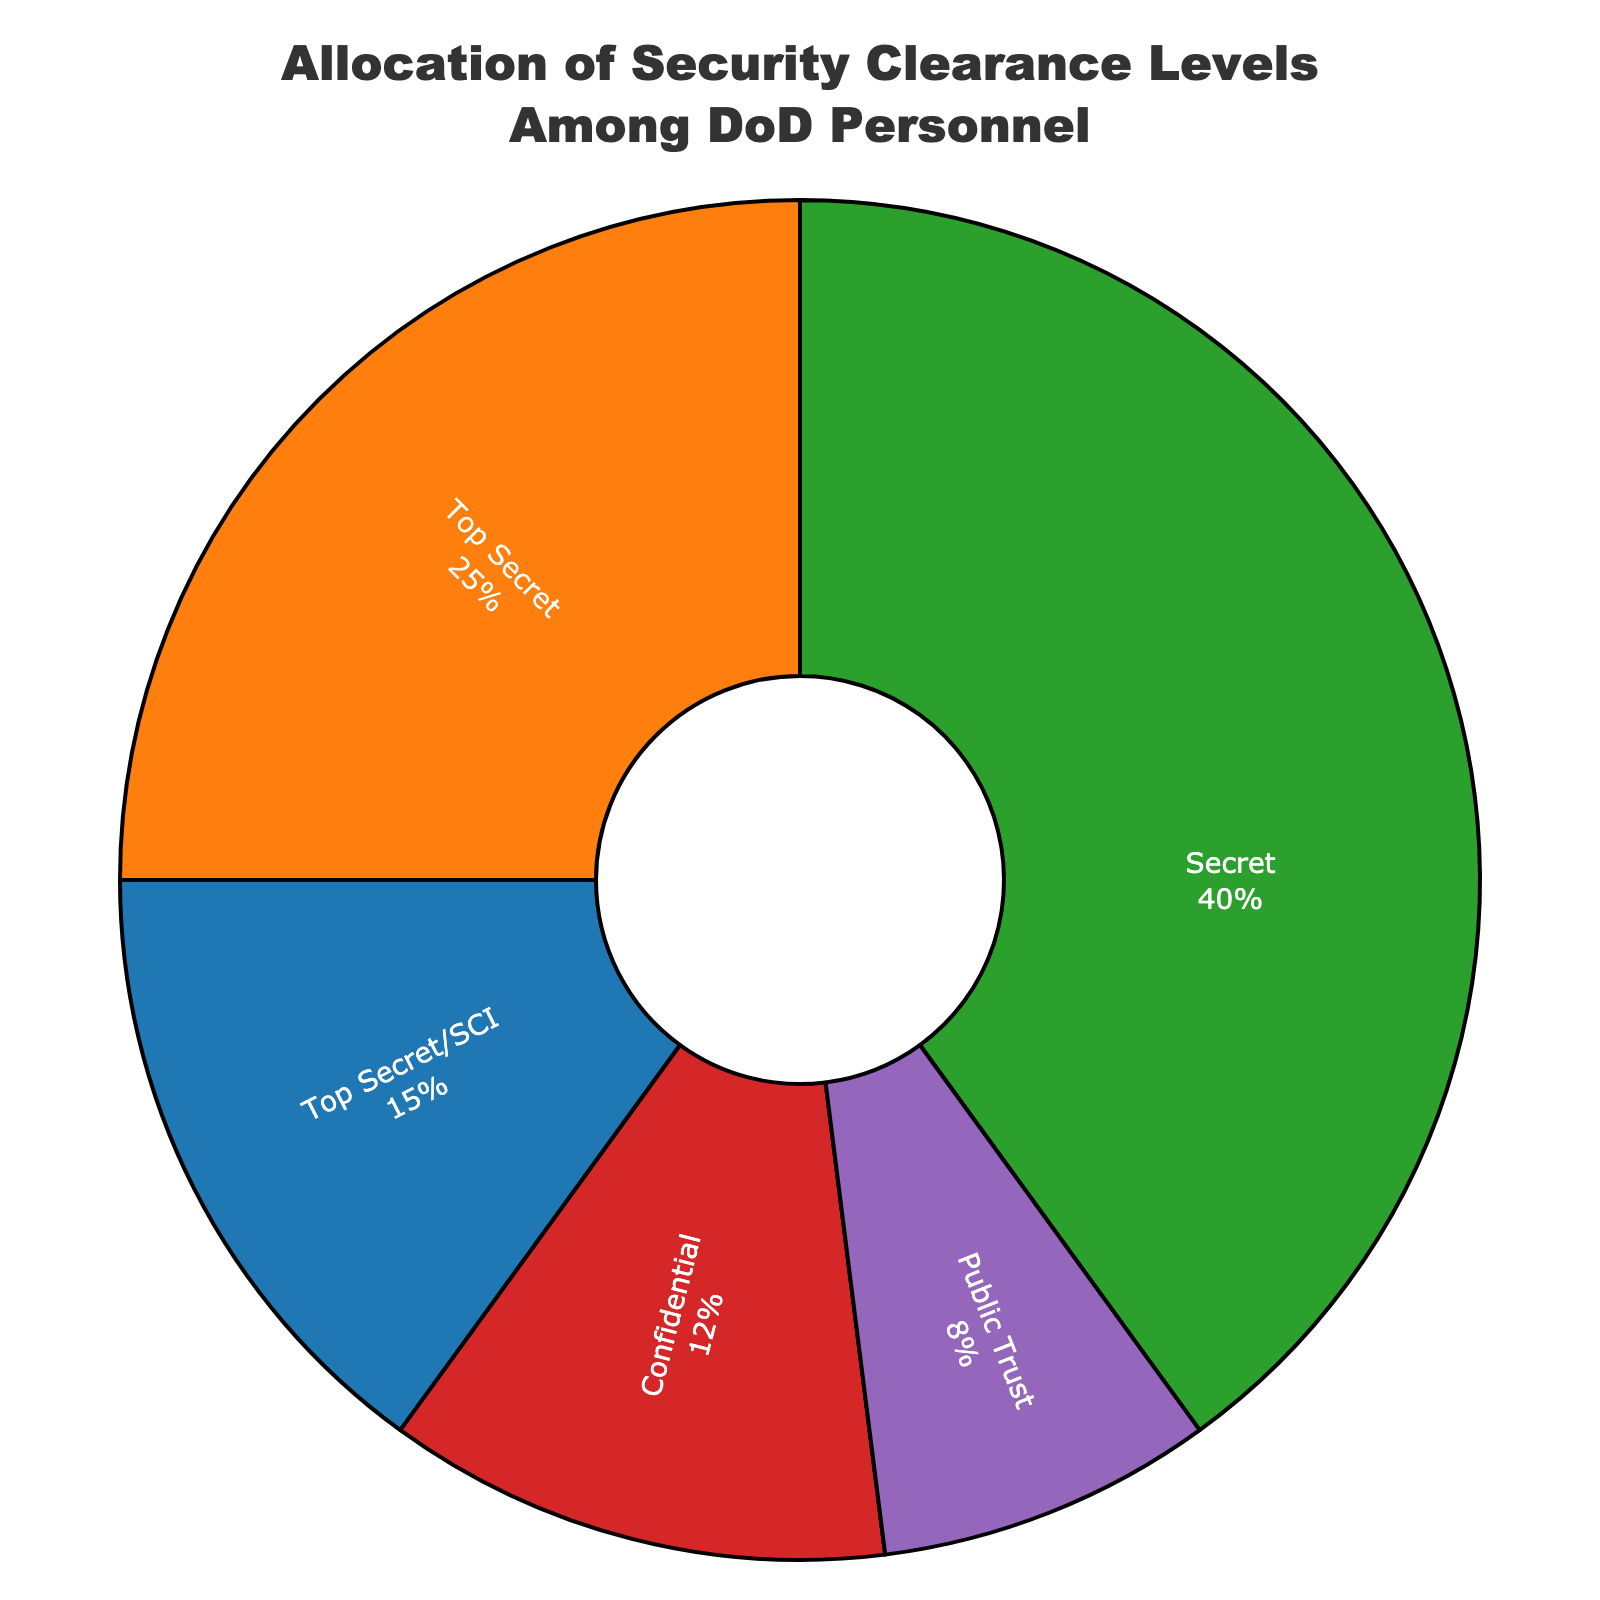What is the most common security clearance level among DoD personnel? The chart shows the percentage allocations of different security clearance levels. The highest percentage represents the most common level. The 'Secret' level has the highest percentage at 40%.
Answer: Secret Which security clearance level is the least common among DoD personnel? The chart shows the percentage allocations of different security clearance levels. The lowest percentage represents the least common level. 'Public Trust' has the lowest percentage at 8%.
Answer: Public Trust What is the combined percentage of personnel with Top Secret and Top Secret/SCI clearances? To find this, sum the percentages for 'Top Secret' (25%) and 'Top Secret/SCI' (15%). 25% + 15% = 40%.
Answer: 40% How does the percentage of personnel with a Secret clearance compare to those with a Confidential clearance? Compare the values from the chart: 'Secret' has 40% and 'Confidential' has 12%. 40% is higher than 12%.
Answer: 40% is higher What is the difference in percentage between personnel with Secret and Public Trust clearances? Subtract the percentage of 'Public Trust' (8%) from 'Secret' (40%). 40% - 8% = 32%.
Answer: 32% What proportion of personnel have either Secret or Confidential clearances? Sum the percentages for 'Secret' (40%) and 'Confidential' (12%). 40% + 12% = 52%.
Answer: 52% Which security clearance level uses the color red? Observing the figure, the 'Confidential' segment is visually represented by the color red.
Answer: Confidential What percentage of DoD personnel do not have a Top Secret clearance? Subtract the percentage for 'Top Secret' (25%) from the total (100%). 100% - 25% = 75%.
Answer: 75% What is the sum of the percentages of all security clearance levels? Since all personnel must fall under one of the given categories, the sum is 100%.
Answer: 100% What is the average percentage allocation among the five security clearance levels? Sum all the percentages and then divide by the number of levels: (15% + 25% + 40% + 12% + 8%) / 5 = 100% / 5 = 20%.
Answer: 20% 